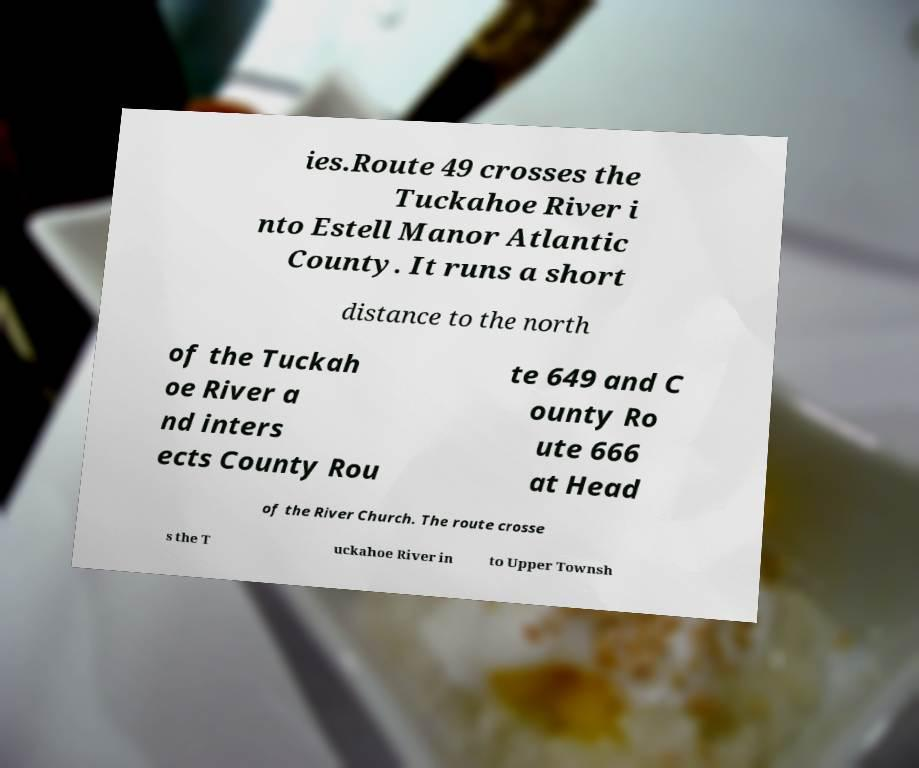Can you read and provide the text displayed in the image?This photo seems to have some interesting text. Can you extract and type it out for me? ies.Route 49 crosses the Tuckahoe River i nto Estell Manor Atlantic County. It runs a short distance to the north of the Tuckah oe River a nd inters ects County Rou te 649 and C ounty Ro ute 666 at Head of the River Church. The route crosse s the T uckahoe River in to Upper Townsh 